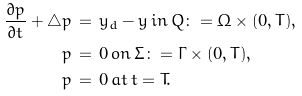Convert formula to latex. <formula><loc_0><loc_0><loc_500><loc_500>\frac { \partial p } { \partial t } + \triangle p \, & = \, y _ { d } - y \, i n \, Q \colon = \Omega \times ( 0 , T ) , \\ p \, & = \, 0 \, o n \, \Sigma \colon = \Gamma \times ( 0 , T ) , \\ p \, & = \, 0 \, a t \, t = T .</formula> 